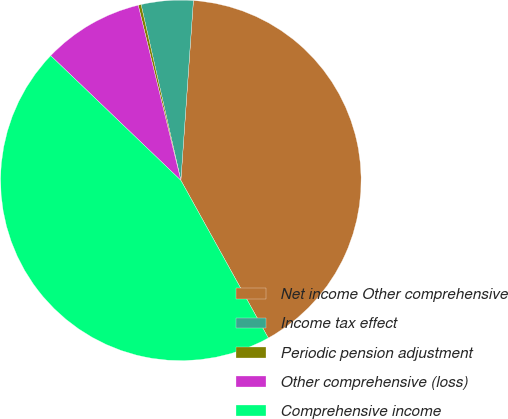<chart> <loc_0><loc_0><loc_500><loc_500><pie_chart><fcel>Net income Other comprehensive<fcel>Income tax effect<fcel>Periodic pension adjustment<fcel>Other comprehensive (loss)<fcel>Comprehensive income<nl><fcel>40.83%<fcel>4.65%<fcel>0.26%<fcel>9.04%<fcel>45.22%<nl></chart> 